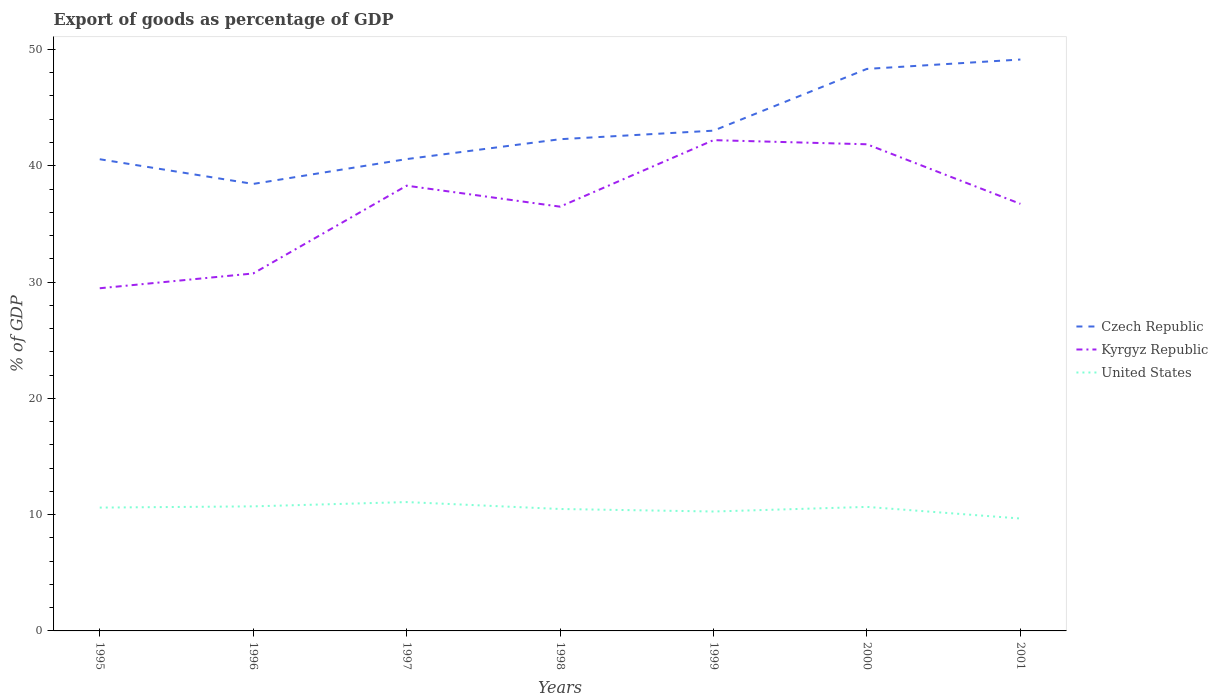Across all years, what is the maximum export of goods as percentage of GDP in United States?
Your response must be concise. 9.67. What is the total export of goods as percentage of GDP in Kyrgyz Republic in the graph?
Offer a terse response. 0.36. What is the difference between the highest and the second highest export of goods as percentage of GDP in Czech Republic?
Make the answer very short. 10.7. What is the difference between the highest and the lowest export of goods as percentage of GDP in Czech Republic?
Provide a short and direct response. 2. How many years are there in the graph?
Give a very brief answer. 7. What is the difference between two consecutive major ticks on the Y-axis?
Provide a short and direct response. 10. Does the graph contain any zero values?
Your response must be concise. No. How many legend labels are there?
Give a very brief answer. 3. How are the legend labels stacked?
Your response must be concise. Vertical. What is the title of the graph?
Provide a succinct answer. Export of goods as percentage of GDP. Does "Maldives" appear as one of the legend labels in the graph?
Your answer should be compact. No. What is the label or title of the X-axis?
Ensure brevity in your answer.  Years. What is the label or title of the Y-axis?
Your answer should be very brief. % of GDP. What is the % of GDP in Czech Republic in 1995?
Give a very brief answer. 40.56. What is the % of GDP of Kyrgyz Republic in 1995?
Provide a short and direct response. 29.47. What is the % of GDP in United States in 1995?
Give a very brief answer. 10.61. What is the % of GDP in Czech Republic in 1996?
Offer a terse response. 38.44. What is the % of GDP in Kyrgyz Republic in 1996?
Your answer should be very brief. 30.74. What is the % of GDP of United States in 1996?
Your answer should be compact. 10.71. What is the % of GDP in Czech Republic in 1997?
Your answer should be very brief. 40.57. What is the % of GDP of Kyrgyz Republic in 1997?
Provide a short and direct response. 38.29. What is the % of GDP in United States in 1997?
Offer a very short reply. 11.08. What is the % of GDP of Czech Republic in 1998?
Your answer should be compact. 42.28. What is the % of GDP in Kyrgyz Republic in 1998?
Provide a succinct answer. 36.48. What is the % of GDP in United States in 1998?
Provide a succinct answer. 10.48. What is the % of GDP in Czech Republic in 1999?
Offer a terse response. 43.02. What is the % of GDP in Kyrgyz Republic in 1999?
Give a very brief answer. 42.2. What is the % of GDP of United States in 1999?
Give a very brief answer. 10.27. What is the % of GDP in Czech Republic in 2000?
Offer a terse response. 48.33. What is the % of GDP of Kyrgyz Republic in 2000?
Your response must be concise. 41.85. What is the % of GDP of United States in 2000?
Your answer should be compact. 10.66. What is the % of GDP in Czech Republic in 2001?
Offer a very short reply. 49.14. What is the % of GDP of Kyrgyz Republic in 2001?
Your answer should be compact. 36.72. What is the % of GDP in United States in 2001?
Offer a terse response. 9.67. Across all years, what is the maximum % of GDP in Czech Republic?
Your response must be concise. 49.14. Across all years, what is the maximum % of GDP of Kyrgyz Republic?
Give a very brief answer. 42.2. Across all years, what is the maximum % of GDP of United States?
Your answer should be compact. 11.08. Across all years, what is the minimum % of GDP in Czech Republic?
Ensure brevity in your answer.  38.44. Across all years, what is the minimum % of GDP of Kyrgyz Republic?
Ensure brevity in your answer.  29.47. Across all years, what is the minimum % of GDP of United States?
Offer a very short reply. 9.67. What is the total % of GDP in Czech Republic in the graph?
Provide a succinct answer. 302.34. What is the total % of GDP in Kyrgyz Republic in the graph?
Provide a short and direct response. 255.75. What is the total % of GDP of United States in the graph?
Keep it short and to the point. 73.48. What is the difference between the % of GDP of Czech Republic in 1995 and that in 1996?
Give a very brief answer. 2.12. What is the difference between the % of GDP of Kyrgyz Republic in 1995 and that in 1996?
Provide a succinct answer. -1.27. What is the difference between the % of GDP in United States in 1995 and that in 1996?
Provide a short and direct response. -0.11. What is the difference between the % of GDP of Czech Republic in 1995 and that in 1997?
Offer a very short reply. -0.01. What is the difference between the % of GDP of Kyrgyz Republic in 1995 and that in 1997?
Your answer should be very brief. -8.82. What is the difference between the % of GDP in United States in 1995 and that in 1997?
Your response must be concise. -0.47. What is the difference between the % of GDP in Czech Republic in 1995 and that in 1998?
Your response must be concise. -1.72. What is the difference between the % of GDP of Kyrgyz Republic in 1995 and that in 1998?
Offer a terse response. -7.02. What is the difference between the % of GDP of United States in 1995 and that in 1998?
Keep it short and to the point. 0.12. What is the difference between the % of GDP of Czech Republic in 1995 and that in 1999?
Give a very brief answer. -2.46. What is the difference between the % of GDP in Kyrgyz Republic in 1995 and that in 1999?
Your answer should be very brief. -12.74. What is the difference between the % of GDP in United States in 1995 and that in 1999?
Your answer should be compact. 0.34. What is the difference between the % of GDP of Czech Republic in 1995 and that in 2000?
Keep it short and to the point. -7.77. What is the difference between the % of GDP in Kyrgyz Republic in 1995 and that in 2000?
Provide a succinct answer. -12.38. What is the difference between the % of GDP of United States in 1995 and that in 2000?
Offer a terse response. -0.06. What is the difference between the % of GDP of Czech Republic in 1995 and that in 2001?
Offer a very short reply. -8.57. What is the difference between the % of GDP of Kyrgyz Republic in 1995 and that in 2001?
Provide a short and direct response. -7.26. What is the difference between the % of GDP of United States in 1995 and that in 2001?
Provide a succinct answer. 0.94. What is the difference between the % of GDP of Czech Republic in 1996 and that in 1997?
Keep it short and to the point. -2.14. What is the difference between the % of GDP of Kyrgyz Republic in 1996 and that in 1997?
Provide a succinct answer. -7.55. What is the difference between the % of GDP of United States in 1996 and that in 1997?
Provide a short and direct response. -0.37. What is the difference between the % of GDP in Czech Republic in 1996 and that in 1998?
Keep it short and to the point. -3.85. What is the difference between the % of GDP in Kyrgyz Republic in 1996 and that in 1998?
Give a very brief answer. -5.75. What is the difference between the % of GDP in United States in 1996 and that in 1998?
Provide a succinct answer. 0.23. What is the difference between the % of GDP in Czech Republic in 1996 and that in 1999?
Give a very brief answer. -4.58. What is the difference between the % of GDP in Kyrgyz Republic in 1996 and that in 1999?
Make the answer very short. -11.46. What is the difference between the % of GDP in United States in 1996 and that in 1999?
Keep it short and to the point. 0.44. What is the difference between the % of GDP of Czech Republic in 1996 and that in 2000?
Ensure brevity in your answer.  -9.89. What is the difference between the % of GDP of Kyrgyz Republic in 1996 and that in 2000?
Your answer should be very brief. -11.11. What is the difference between the % of GDP in United States in 1996 and that in 2000?
Keep it short and to the point. 0.05. What is the difference between the % of GDP of Czech Republic in 1996 and that in 2001?
Your answer should be very brief. -10.7. What is the difference between the % of GDP in Kyrgyz Republic in 1996 and that in 2001?
Your answer should be compact. -5.99. What is the difference between the % of GDP of United States in 1996 and that in 2001?
Offer a terse response. 1.04. What is the difference between the % of GDP in Czech Republic in 1997 and that in 1998?
Keep it short and to the point. -1.71. What is the difference between the % of GDP of Kyrgyz Republic in 1997 and that in 1998?
Ensure brevity in your answer.  1.8. What is the difference between the % of GDP in United States in 1997 and that in 1998?
Provide a short and direct response. 0.59. What is the difference between the % of GDP of Czech Republic in 1997 and that in 1999?
Your answer should be compact. -2.44. What is the difference between the % of GDP of Kyrgyz Republic in 1997 and that in 1999?
Provide a short and direct response. -3.92. What is the difference between the % of GDP of United States in 1997 and that in 1999?
Provide a succinct answer. 0.81. What is the difference between the % of GDP in Czech Republic in 1997 and that in 2000?
Offer a very short reply. -7.76. What is the difference between the % of GDP of Kyrgyz Republic in 1997 and that in 2000?
Keep it short and to the point. -3.56. What is the difference between the % of GDP of United States in 1997 and that in 2000?
Your answer should be compact. 0.42. What is the difference between the % of GDP in Czech Republic in 1997 and that in 2001?
Provide a succinct answer. -8.56. What is the difference between the % of GDP in Kyrgyz Republic in 1997 and that in 2001?
Offer a terse response. 1.56. What is the difference between the % of GDP in United States in 1997 and that in 2001?
Provide a short and direct response. 1.41. What is the difference between the % of GDP of Czech Republic in 1998 and that in 1999?
Ensure brevity in your answer.  -0.74. What is the difference between the % of GDP in Kyrgyz Republic in 1998 and that in 1999?
Ensure brevity in your answer.  -5.72. What is the difference between the % of GDP in United States in 1998 and that in 1999?
Give a very brief answer. 0.22. What is the difference between the % of GDP in Czech Republic in 1998 and that in 2000?
Your response must be concise. -6.05. What is the difference between the % of GDP in Kyrgyz Republic in 1998 and that in 2000?
Ensure brevity in your answer.  -5.36. What is the difference between the % of GDP in United States in 1998 and that in 2000?
Offer a terse response. -0.18. What is the difference between the % of GDP in Czech Republic in 1998 and that in 2001?
Your answer should be compact. -6.85. What is the difference between the % of GDP of Kyrgyz Republic in 1998 and that in 2001?
Make the answer very short. -0.24. What is the difference between the % of GDP of United States in 1998 and that in 2001?
Offer a very short reply. 0.82. What is the difference between the % of GDP of Czech Republic in 1999 and that in 2000?
Offer a terse response. -5.31. What is the difference between the % of GDP of Kyrgyz Republic in 1999 and that in 2000?
Give a very brief answer. 0.36. What is the difference between the % of GDP of United States in 1999 and that in 2000?
Provide a short and direct response. -0.4. What is the difference between the % of GDP in Czech Republic in 1999 and that in 2001?
Ensure brevity in your answer.  -6.12. What is the difference between the % of GDP of Kyrgyz Republic in 1999 and that in 2001?
Provide a short and direct response. 5.48. What is the difference between the % of GDP in United States in 1999 and that in 2001?
Provide a short and direct response. 0.6. What is the difference between the % of GDP of Czech Republic in 2000 and that in 2001?
Your answer should be very brief. -0.81. What is the difference between the % of GDP of Kyrgyz Republic in 2000 and that in 2001?
Offer a very short reply. 5.12. What is the difference between the % of GDP in Czech Republic in 1995 and the % of GDP in Kyrgyz Republic in 1996?
Provide a succinct answer. 9.82. What is the difference between the % of GDP in Czech Republic in 1995 and the % of GDP in United States in 1996?
Your answer should be compact. 29.85. What is the difference between the % of GDP in Kyrgyz Republic in 1995 and the % of GDP in United States in 1996?
Provide a short and direct response. 18.76. What is the difference between the % of GDP of Czech Republic in 1995 and the % of GDP of Kyrgyz Republic in 1997?
Offer a terse response. 2.27. What is the difference between the % of GDP of Czech Republic in 1995 and the % of GDP of United States in 1997?
Give a very brief answer. 29.48. What is the difference between the % of GDP in Kyrgyz Republic in 1995 and the % of GDP in United States in 1997?
Your answer should be very brief. 18.39. What is the difference between the % of GDP in Czech Republic in 1995 and the % of GDP in Kyrgyz Republic in 1998?
Offer a very short reply. 4.08. What is the difference between the % of GDP in Czech Republic in 1995 and the % of GDP in United States in 1998?
Provide a succinct answer. 30.08. What is the difference between the % of GDP in Kyrgyz Republic in 1995 and the % of GDP in United States in 1998?
Provide a short and direct response. 18.98. What is the difference between the % of GDP of Czech Republic in 1995 and the % of GDP of Kyrgyz Republic in 1999?
Give a very brief answer. -1.64. What is the difference between the % of GDP in Czech Republic in 1995 and the % of GDP in United States in 1999?
Give a very brief answer. 30.29. What is the difference between the % of GDP in Kyrgyz Republic in 1995 and the % of GDP in United States in 1999?
Give a very brief answer. 19.2. What is the difference between the % of GDP in Czech Republic in 1995 and the % of GDP in Kyrgyz Republic in 2000?
Your answer should be compact. -1.29. What is the difference between the % of GDP in Czech Republic in 1995 and the % of GDP in United States in 2000?
Your answer should be compact. 29.9. What is the difference between the % of GDP in Kyrgyz Republic in 1995 and the % of GDP in United States in 2000?
Make the answer very short. 18.8. What is the difference between the % of GDP of Czech Republic in 1995 and the % of GDP of Kyrgyz Republic in 2001?
Offer a terse response. 3.84. What is the difference between the % of GDP in Czech Republic in 1995 and the % of GDP in United States in 2001?
Offer a terse response. 30.9. What is the difference between the % of GDP of Kyrgyz Republic in 1995 and the % of GDP of United States in 2001?
Provide a short and direct response. 19.8. What is the difference between the % of GDP in Czech Republic in 1996 and the % of GDP in Kyrgyz Republic in 1997?
Your answer should be compact. 0.15. What is the difference between the % of GDP in Czech Republic in 1996 and the % of GDP in United States in 1997?
Your response must be concise. 27.36. What is the difference between the % of GDP of Kyrgyz Republic in 1996 and the % of GDP of United States in 1997?
Offer a terse response. 19.66. What is the difference between the % of GDP in Czech Republic in 1996 and the % of GDP in Kyrgyz Republic in 1998?
Offer a very short reply. 1.95. What is the difference between the % of GDP in Czech Republic in 1996 and the % of GDP in United States in 1998?
Ensure brevity in your answer.  27.95. What is the difference between the % of GDP of Kyrgyz Republic in 1996 and the % of GDP of United States in 1998?
Make the answer very short. 20.25. What is the difference between the % of GDP in Czech Republic in 1996 and the % of GDP in Kyrgyz Republic in 1999?
Provide a short and direct response. -3.77. What is the difference between the % of GDP in Czech Republic in 1996 and the % of GDP in United States in 1999?
Give a very brief answer. 28.17. What is the difference between the % of GDP in Kyrgyz Republic in 1996 and the % of GDP in United States in 1999?
Give a very brief answer. 20.47. What is the difference between the % of GDP of Czech Republic in 1996 and the % of GDP of Kyrgyz Republic in 2000?
Provide a succinct answer. -3.41. What is the difference between the % of GDP in Czech Republic in 1996 and the % of GDP in United States in 2000?
Offer a terse response. 27.77. What is the difference between the % of GDP of Kyrgyz Republic in 1996 and the % of GDP of United States in 2000?
Offer a very short reply. 20.07. What is the difference between the % of GDP of Czech Republic in 1996 and the % of GDP of Kyrgyz Republic in 2001?
Give a very brief answer. 1.71. What is the difference between the % of GDP of Czech Republic in 1996 and the % of GDP of United States in 2001?
Your answer should be very brief. 28.77. What is the difference between the % of GDP of Kyrgyz Republic in 1996 and the % of GDP of United States in 2001?
Your response must be concise. 21.07. What is the difference between the % of GDP in Czech Republic in 1997 and the % of GDP in Kyrgyz Republic in 1998?
Your answer should be very brief. 4.09. What is the difference between the % of GDP in Czech Republic in 1997 and the % of GDP in United States in 1998?
Keep it short and to the point. 30.09. What is the difference between the % of GDP of Kyrgyz Republic in 1997 and the % of GDP of United States in 1998?
Provide a short and direct response. 27.8. What is the difference between the % of GDP in Czech Republic in 1997 and the % of GDP in Kyrgyz Republic in 1999?
Your answer should be very brief. -1.63. What is the difference between the % of GDP in Czech Republic in 1997 and the % of GDP in United States in 1999?
Ensure brevity in your answer.  30.31. What is the difference between the % of GDP of Kyrgyz Republic in 1997 and the % of GDP of United States in 1999?
Make the answer very short. 28.02. What is the difference between the % of GDP of Czech Republic in 1997 and the % of GDP of Kyrgyz Republic in 2000?
Your answer should be compact. -1.27. What is the difference between the % of GDP in Czech Republic in 1997 and the % of GDP in United States in 2000?
Keep it short and to the point. 29.91. What is the difference between the % of GDP of Kyrgyz Republic in 1997 and the % of GDP of United States in 2000?
Offer a very short reply. 27.62. What is the difference between the % of GDP of Czech Republic in 1997 and the % of GDP of Kyrgyz Republic in 2001?
Make the answer very short. 3.85. What is the difference between the % of GDP in Czech Republic in 1997 and the % of GDP in United States in 2001?
Your response must be concise. 30.91. What is the difference between the % of GDP of Kyrgyz Republic in 1997 and the % of GDP of United States in 2001?
Provide a succinct answer. 28.62. What is the difference between the % of GDP of Czech Republic in 1998 and the % of GDP of Kyrgyz Republic in 1999?
Your response must be concise. 0.08. What is the difference between the % of GDP in Czech Republic in 1998 and the % of GDP in United States in 1999?
Provide a succinct answer. 32.02. What is the difference between the % of GDP in Kyrgyz Republic in 1998 and the % of GDP in United States in 1999?
Your answer should be compact. 26.21. What is the difference between the % of GDP of Czech Republic in 1998 and the % of GDP of Kyrgyz Republic in 2000?
Your response must be concise. 0.44. What is the difference between the % of GDP of Czech Republic in 1998 and the % of GDP of United States in 2000?
Make the answer very short. 31.62. What is the difference between the % of GDP in Kyrgyz Republic in 1998 and the % of GDP in United States in 2000?
Give a very brief answer. 25.82. What is the difference between the % of GDP in Czech Republic in 1998 and the % of GDP in Kyrgyz Republic in 2001?
Provide a short and direct response. 5.56. What is the difference between the % of GDP in Czech Republic in 1998 and the % of GDP in United States in 2001?
Offer a terse response. 32.62. What is the difference between the % of GDP of Kyrgyz Republic in 1998 and the % of GDP of United States in 2001?
Offer a very short reply. 26.82. What is the difference between the % of GDP in Czech Republic in 1999 and the % of GDP in Kyrgyz Republic in 2000?
Provide a succinct answer. 1.17. What is the difference between the % of GDP of Czech Republic in 1999 and the % of GDP of United States in 2000?
Ensure brevity in your answer.  32.35. What is the difference between the % of GDP in Kyrgyz Republic in 1999 and the % of GDP in United States in 2000?
Ensure brevity in your answer.  31.54. What is the difference between the % of GDP in Czech Republic in 1999 and the % of GDP in Kyrgyz Republic in 2001?
Your response must be concise. 6.29. What is the difference between the % of GDP of Czech Republic in 1999 and the % of GDP of United States in 2001?
Provide a short and direct response. 33.35. What is the difference between the % of GDP of Kyrgyz Republic in 1999 and the % of GDP of United States in 2001?
Your answer should be very brief. 32.54. What is the difference between the % of GDP of Czech Republic in 2000 and the % of GDP of Kyrgyz Republic in 2001?
Keep it short and to the point. 11.61. What is the difference between the % of GDP in Czech Republic in 2000 and the % of GDP in United States in 2001?
Offer a terse response. 38.66. What is the difference between the % of GDP in Kyrgyz Republic in 2000 and the % of GDP in United States in 2001?
Your answer should be very brief. 32.18. What is the average % of GDP in Czech Republic per year?
Give a very brief answer. 43.19. What is the average % of GDP in Kyrgyz Republic per year?
Your answer should be very brief. 36.54. What is the average % of GDP of United States per year?
Ensure brevity in your answer.  10.5. In the year 1995, what is the difference between the % of GDP of Czech Republic and % of GDP of Kyrgyz Republic?
Offer a very short reply. 11.09. In the year 1995, what is the difference between the % of GDP of Czech Republic and % of GDP of United States?
Keep it short and to the point. 29.96. In the year 1995, what is the difference between the % of GDP of Kyrgyz Republic and % of GDP of United States?
Provide a short and direct response. 18.86. In the year 1996, what is the difference between the % of GDP of Czech Republic and % of GDP of Kyrgyz Republic?
Provide a succinct answer. 7.7. In the year 1996, what is the difference between the % of GDP of Czech Republic and % of GDP of United States?
Offer a terse response. 27.73. In the year 1996, what is the difference between the % of GDP in Kyrgyz Republic and % of GDP in United States?
Provide a succinct answer. 20.03. In the year 1997, what is the difference between the % of GDP of Czech Republic and % of GDP of Kyrgyz Republic?
Keep it short and to the point. 2.29. In the year 1997, what is the difference between the % of GDP in Czech Republic and % of GDP in United States?
Your response must be concise. 29.49. In the year 1997, what is the difference between the % of GDP in Kyrgyz Republic and % of GDP in United States?
Offer a terse response. 27.21. In the year 1998, what is the difference between the % of GDP of Czech Republic and % of GDP of Kyrgyz Republic?
Provide a short and direct response. 5.8. In the year 1998, what is the difference between the % of GDP of Czech Republic and % of GDP of United States?
Provide a succinct answer. 31.8. In the year 1998, what is the difference between the % of GDP of Kyrgyz Republic and % of GDP of United States?
Make the answer very short. 26. In the year 1999, what is the difference between the % of GDP in Czech Republic and % of GDP in Kyrgyz Republic?
Ensure brevity in your answer.  0.82. In the year 1999, what is the difference between the % of GDP of Czech Republic and % of GDP of United States?
Make the answer very short. 32.75. In the year 1999, what is the difference between the % of GDP of Kyrgyz Republic and % of GDP of United States?
Offer a terse response. 31.93. In the year 2000, what is the difference between the % of GDP of Czech Republic and % of GDP of Kyrgyz Republic?
Provide a succinct answer. 6.48. In the year 2000, what is the difference between the % of GDP in Czech Republic and % of GDP in United States?
Keep it short and to the point. 37.66. In the year 2000, what is the difference between the % of GDP of Kyrgyz Republic and % of GDP of United States?
Your response must be concise. 31.18. In the year 2001, what is the difference between the % of GDP of Czech Republic and % of GDP of Kyrgyz Republic?
Give a very brief answer. 12.41. In the year 2001, what is the difference between the % of GDP of Czech Republic and % of GDP of United States?
Keep it short and to the point. 39.47. In the year 2001, what is the difference between the % of GDP in Kyrgyz Republic and % of GDP in United States?
Ensure brevity in your answer.  27.06. What is the ratio of the % of GDP of Czech Republic in 1995 to that in 1996?
Give a very brief answer. 1.06. What is the ratio of the % of GDP in Kyrgyz Republic in 1995 to that in 1996?
Provide a succinct answer. 0.96. What is the ratio of the % of GDP in United States in 1995 to that in 1996?
Your answer should be compact. 0.99. What is the ratio of the % of GDP in Czech Republic in 1995 to that in 1997?
Your answer should be very brief. 1. What is the ratio of the % of GDP in Kyrgyz Republic in 1995 to that in 1997?
Offer a very short reply. 0.77. What is the ratio of the % of GDP of United States in 1995 to that in 1997?
Make the answer very short. 0.96. What is the ratio of the % of GDP in Czech Republic in 1995 to that in 1998?
Your answer should be compact. 0.96. What is the ratio of the % of GDP in Kyrgyz Republic in 1995 to that in 1998?
Give a very brief answer. 0.81. What is the ratio of the % of GDP in United States in 1995 to that in 1998?
Your answer should be very brief. 1.01. What is the ratio of the % of GDP of Czech Republic in 1995 to that in 1999?
Your answer should be very brief. 0.94. What is the ratio of the % of GDP of Kyrgyz Republic in 1995 to that in 1999?
Give a very brief answer. 0.7. What is the ratio of the % of GDP of United States in 1995 to that in 1999?
Provide a succinct answer. 1.03. What is the ratio of the % of GDP of Czech Republic in 1995 to that in 2000?
Give a very brief answer. 0.84. What is the ratio of the % of GDP of Kyrgyz Republic in 1995 to that in 2000?
Keep it short and to the point. 0.7. What is the ratio of the % of GDP of Czech Republic in 1995 to that in 2001?
Your answer should be compact. 0.83. What is the ratio of the % of GDP of Kyrgyz Republic in 1995 to that in 2001?
Provide a succinct answer. 0.8. What is the ratio of the % of GDP of United States in 1995 to that in 2001?
Your response must be concise. 1.1. What is the ratio of the % of GDP of Czech Republic in 1996 to that in 1997?
Provide a short and direct response. 0.95. What is the ratio of the % of GDP in Kyrgyz Republic in 1996 to that in 1997?
Offer a very short reply. 0.8. What is the ratio of the % of GDP in United States in 1996 to that in 1997?
Make the answer very short. 0.97. What is the ratio of the % of GDP in Kyrgyz Republic in 1996 to that in 1998?
Keep it short and to the point. 0.84. What is the ratio of the % of GDP in United States in 1996 to that in 1998?
Offer a very short reply. 1.02. What is the ratio of the % of GDP of Czech Republic in 1996 to that in 1999?
Make the answer very short. 0.89. What is the ratio of the % of GDP of Kyrgyz Republic in 1996 to that in 1999?
Ensure brevity in your answer.  0.73. What is the ratio of the % of GDP in United States in 1996 to that in 1999?
Your answer should be compact. 1.04. What is the ratio of the % of GDP of Czech Republic in 1996 to that in 2000?
Your response must be concise. 0.8. What is the ratio of the % of GDP in Kyrgyz Republic in 1996 to that in 2000?
Your answer should be very brief. 0.73. What is the ratio of the % of GDP of Czech Republic in 1996 to that in 2001?
Make the answer very short. 0.78. What is the ratio of the % of GDP in Kyrgyz Republic in 1996 to that in 2001?
Ensure brevity in your answer.  0.84. What is the ratio of the % of GDP of United States in 1996 to that in 2001?
Keep it short and to the point. 1.11. What is the ratio of the % of GDP in Czech Republic in 1997 to that in 1998?
Offer a terse response. 0.96. What is the ratio of the % of GDP of Kyrgyz Republic in 1997 to that in 1998?
Make the answer very short. 1.05. What is the ratio of the % of GDP in United States in 1997 to that in 1998?
Your answer should be very brief. 1.06. What is the ratio of the % of GDP of Czech Republic in 1997 to that in 1999?
Offer a very short reply. 0.94. What is the ratio of the % of GDP of Kyrgyz Republic in 1997 to that in 1999?
Your answer should be very brief. 0.91. What is the ratio of the % of GDP of United States in 1997 to that in 1999?
Your answer should be very brief. 1.08. What is the ratio of the % of GDP in Czech Republic in 1997 to that in 2000?
Ensure brevity in your answer.  0.84. What is the ratio of the % of GDP of Kyrgyz Republic in 1997 to that in 2000?
Your response must be concise. 0.91. What is the ratio of the % of GDP of United States in 1997 to that in 2000?
Make the answer very short. 1.04. What is the ratio of the % of GDP of Czech Republic in 1997 to that in 2001?
Provide a succinct answer. 0.83. What is the ratio of the % of GDP of Kyrgyz Republic in 1997 to that in 2001?
Offer a terse response. 1.04. What is the ratio of the % of GDP in United States in 1997 to that in 2001?
Provide a short and direct response. 1.15. What is the ratio of the % of GDP of Czech Republic in 1998 to that in 1999?
Give a very brief answer. 0.98. What is the ratio of the % of GDP of Kyrgyz Republic in 1998 to that in 1999?
Provide a short and direct response. 0.86. What is the ratio of the % of GDP in United States in 1998 to that in 1999?
Provide a succinct answer. 1.02. What is the ratio of the % of GDP of Czech Republic in 1998 to that in 2000?
Provide a short and direct response. 0.87. What is the ratio of the % of GDP of Kyrgyz Republic in 1998 to that in 2000?
Provide a short and direct response. 0.87. What is the ratio of the % of GDP of United States in 1998 to that in 2000?
Keep it short and to the point. 0.98. What is the ratio of the % of GDP in Czech Republic in 1998 to that in 2001?
Give a very brief answer. 0.86. What is the ratio of the % of GDP of Kyrgyz Republic in 1998 to that in 2001?
Your response must be concise. 0.99. What is the ratio of the % of GDP in United States in 1998 to that in 2001?
Give a very brief answer. 1.08. What is the ratio of the % of GDP of Czech Republic in 1999 to that in 2000?
Provide a short and direct response. 0.89. What is the ratio of the % of GDP in Kyrgyz Republic in 1999 to that in 2000?
Provide a succinct answer. 1.01. What is the ratio of the % of GDP in United States in 1999 to that in 2000?
Give a very brief answer. 0.96. What is the ratio of the % of GDP in Czech Republic in 1999 to that in 2001?
Make the answer very short. 0.88. What is the ratio of the % of GDP in Kyrgyz Republic in 1999 to that in 2001?
Provide a succinct answer. 1.15. What is the ratio of the % of GDP of United States in 1999 to that in 2001?
Offer a very short reply. 1.06. What is the ratio of the % of GDP of Czech Republic in 2000 to that in 2001?
Provide a succinct answer. 0.98. What is the ratio of the % of GDP of Kyrgyz Republic in 2000 to that in 2001?
Ensure brevity in your answer.  1.14. What is the ratio of the % of GDP in United States in 2000 to that in 2001?
Your answer should be compact. 1.1. What is the difference between the highest and the second highest % of GDP of Czech Republic?
Provide a succinct answer. 0.81. What is the difference between the highest and the second highest % of GDP of Kyrgyz Republic?
Offer a terse response. 0.36. What is the difference between the highest and the second highest % of GDP in United States?
Keep it short and to the point. 0.37. What is the difference between the highest and the lowest % of GDP of Czech Republic?
Ensure brevity in your answer.  10.7. What is the difference between the highest and the lowest % of GDP in Kyrgyz Republic?
Keep it short and to the point. 12.74. What is the difference between the highest and the lowest % of GDP in United States?
Offer a very short reply. 1.41. 